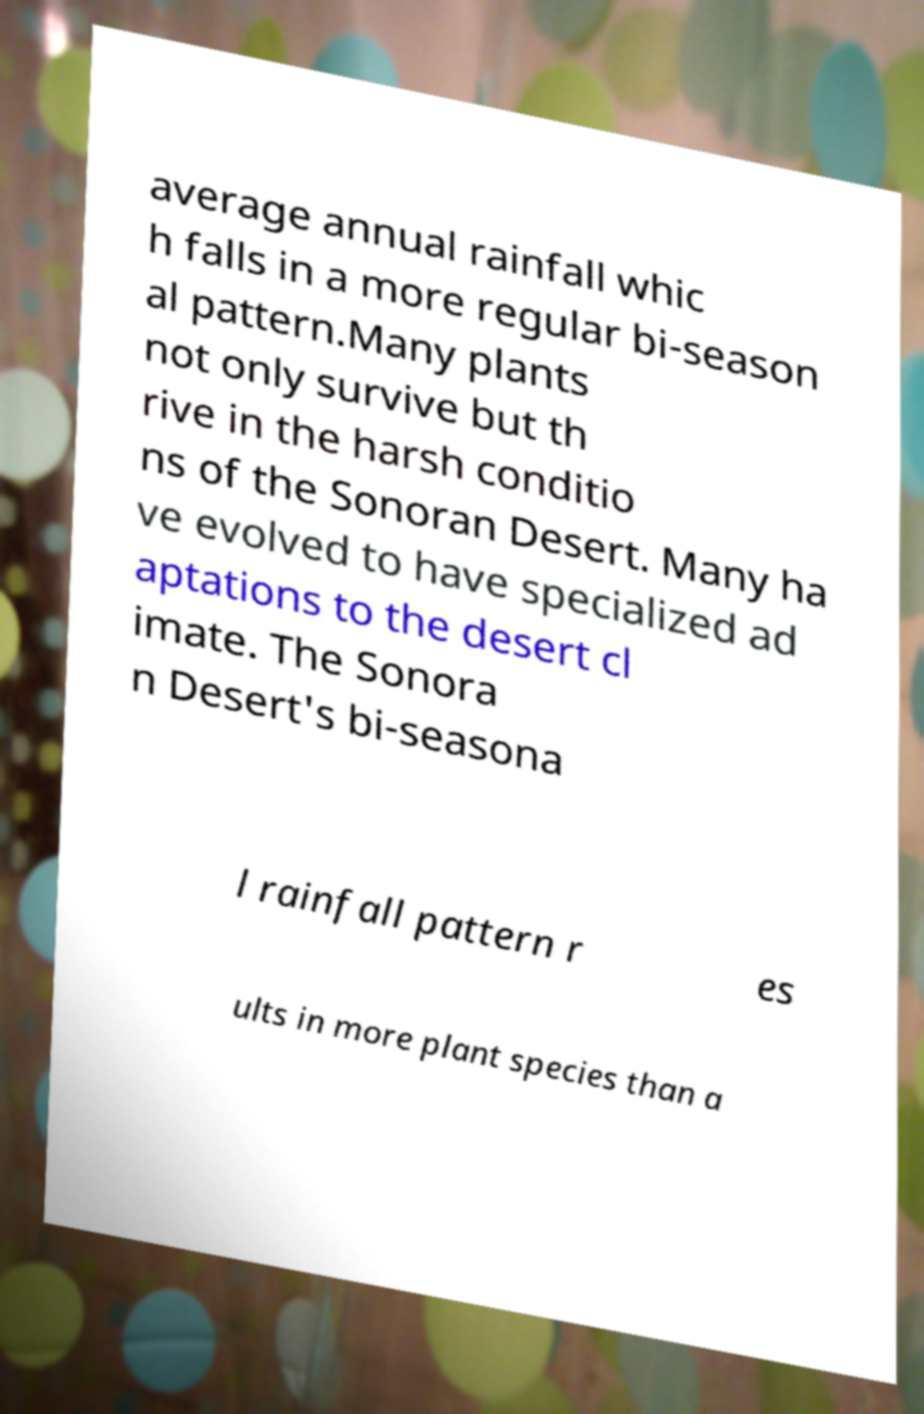Could you assist in decoding the text presented in this image and type it out clearly? average annual rainfall whic h falls in a more regular bi-season al pattern.Many plants not only survive but th rive in the harsh conditio ns of the Sonoran Desert. Many ha ve evolved to have specialized ad aptations to the desert cl imate. The Sonora n Desert's bi-seasona l rainfall pattern r es ults in more plant species than a 